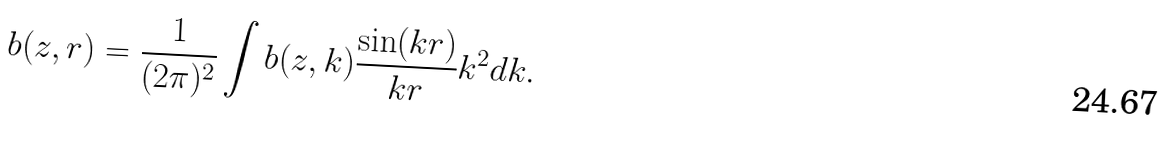<formula> <loc_0><loc_0><loc_500><loc_500>b ( z , r ) = \frac { 1 } { ( 2 \pi ) ^ { 2 } } \int b ( z , k ) \frac { \sin ( k r ) } { k r } k ^ { 2 } d k .</formula> 